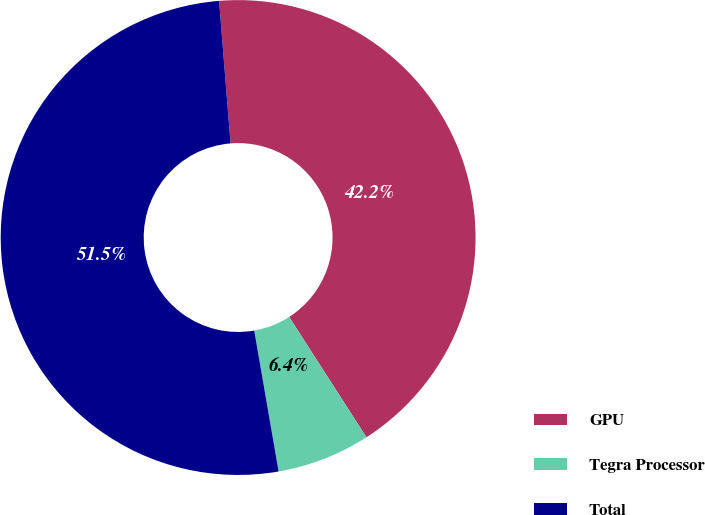Convert chart to OTSL. <chart><loc_0><loc_0><loc_500><loc_500><pie_chart><fcel>GPU<fcel>Tegra Processor<fcel>Total<nl><fcel>42.19%<fcel>6.36%<fcel>51.45%<nl></chart> 